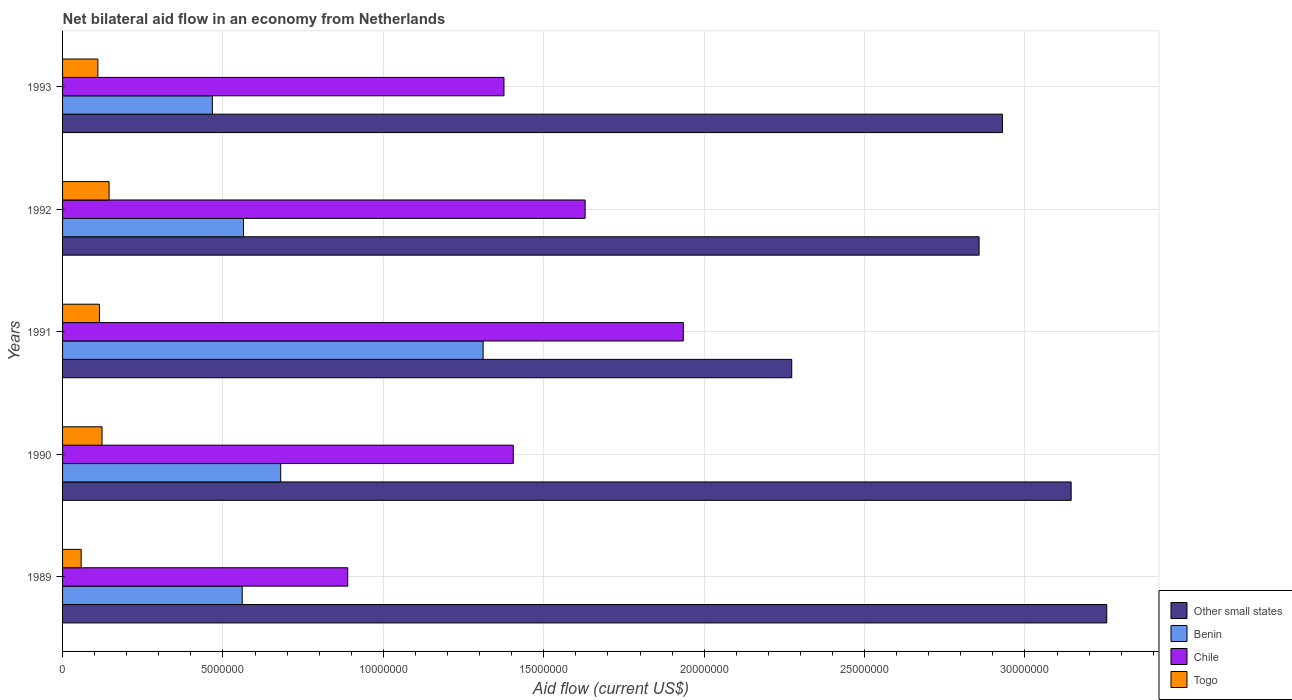How many different coloured bars are there?
Offer a very short reply. 4. How many groups of bars are there?
Ensure brevity in your answer.  5. How many bars are there on the 2nd tick from the top?
Ensure brevity in your answer.  4. How many bars are there on the 4th tick from the bottom?
Provide a short and direct response. 4. In how many cases, is the number of bars for a given year not equal to the number of legend labels?
Provide a short and direct response. 0. What is the net bilateral aid flow in Other small states in 1990?
Provide a succinct answer. 3.14e+07. Across all years, what is the maximum net bilateral aid flow in Benin?
Provide a succinct answer. 1.31e+07. Across all years, what is the minimum net bilateral aid flow in Other small states?
Give a very brief answer. 2.27e+07. In which year was the net bilateral aid flow in Togo maximum?
Your response must be concise. 1992. What is the total net bilateral aid flow in Chile in the graph?
Keep it short and to the point. 7.23e+07. What is the difference between the net bilateral aid flow in Other small states in 1990 and that in 1992?
Make the answer very short. 2.87e+06. What is the difference between the net bilateral aid flow in Chile in 1993 and the net bilateral aid flow in Benin in 1991?
Your answer should be compact. 6.50e+05. What is the average net bilateral aid flow in Chile per year?
Provide a short and direct response. 1.45e+07. In the year 1989, what is the difference between the net bilateral aid flow in Togo and net bilateral aid flow in Benin?
Your response must be concise. -5.02e+06. What is the ratio of the net bilateral aid flow in Benin in 1992 to that in 1993?
Make the answer very short. 1.21. What is the difference between the highest and the second highest net bilateral aid flow in Chile?
Make the answer very short. 3.06e+06. What is the difference between the highest and the lowest net bilateral aid flow in Benin?
Provide a succinct answer. 8.44e+06. In how many years, is the net bilateral aid flow in Togo greater than the average net bilateral aid flow in Togo taken over all years?
Give a very brief answer. 3. Is the sum of the net bilateral aid flow in Other small states in 1989 and 1990 greater than the maximum net bilateral aid flow in Benin across all years?
Offer a very short reply. Yes. Is it the case that in every year, the sum of the net bilateral aid flow in Other small states and net bilateral aid flow in Chile is greater than the sum of net bilateral aid flow in Togo and net bilateral aid flow in Benin?
Give a very brief answer. Yes. What does the 1st bar from the top in 1989 represents?
Your answer should be compact. Togo. What does the 1st bar from the bottom in 1991 represents?
Offer a very short reply. Other small states. How many bars are there?
Make the answer very short. 20. How many years are there in the graph?
Provide a succinct answer. 5. What is the difference between two consecutive major ticks on the X-axis?
Your response must be concise. 5.00e+06. Does the graph contain any zero values?
Provide a short and direct response. No. Does the graph contain grids?
Ensure brevity in your answer.  Yes. What is the title of the graph?
Keep it short and to the point. Net bilateral aid flow in an economy from Netherlands. Does "Cote d'Ivoire" appear as one of the legend labels in the graph?
Offer a terse response. No. What is the label or title of the X-axis?
Offer a terse response. Aid flow (current US$). What is the label or title of the Y-axis?
Make the answer very short. Years. What is the Aid flow (current US$) of Other small states in 1989?
Keep it short and to the point. 3.26e+07. What is the Aid flow (current US$) of Benin in 1989?
Ensure brevity in your answer.  5.60e+06. What is the Aid flow (current US$) in Chile in 1989?
Your answer should be compact. 8.89e+06. What is the Aid flow (current US$) of Togo in 1989?
Your answer should be compact. 5.80e+05. What is the Aid flow (current US$) in Other small states in 1990?
Give a very brief answer. 3.14e+07. What is the Aid flow (current US$) of Benin in 1990?
Give a very brief answer. 6.80e+06. What is the Aid flow (current US$) in Chile in 1990?
Keep it short and to the point. 1.40e+07. What is the Aid flow (current US$) in Togo in 1990?
Make the answer very short. 1.23e+06. What is the Aid flow (current US$) of Other small states in 1991?
Keep it short and to the point. 2.27e+07. What is the Aid flow (current US$) in Benin in 1991?
Provide a short and direct response. 1.31e+07. What is the Aid flow (current US$) of Chile in 1991?
Give a very brief answer. 1.94e+07. What is the Aid flow (current US$) of Togo in 1991?
Provide a short and direct response. 1.15e+06. What is the Aid flow (current US$) in Other small states in 1992?
Make the answer very short. 2.86e+07. What is the Aid flow (current US$) in Benin in 1992?
Make the answer very short. 5.64e+06. What is the Aid flow (current US$) of Chile in 1992?
Ensure brevity in your answer.  1.63e+07. What is the Aid flow (current US$) in Togo in 1992?
Offer a very short reply. 1.45e+06. What is the Aid flow (current US$) in Other small states in 1993?
Offer a terse response. 2.93e+07. What is the Aid flow (current US$) in Benin in 1993?
Offer a very short reply. 4.67e+06. What is the Aid flow (current US$) of Chile in 1993?
Provide a succinct answer. 1.38e+07. What is the Aid flow (current US$) of Togo in 1993?
Offer a terse response. 1.10e+06. Across all years, what is the maximum Aid flow (current US$) of Other small states?
Your answer should be compact. 3.26e+07. Across all years, what is the maximum Aid flow (current US$) of Benin?
Ensure brevity in your answer.  1.31e+07. Across all years, what is the maximum Aid flow (current US$) of Chile?
Offer a very short reply. 1.94e+07. Across all years, what is the maximum Aid flow (current US$) of Togo?
Your answer should be very brief. 1.45e+06. Across all years, what is the minimum Aid flow (current US$) of Other small states?
Your answer should be very brief. 2.27e+07. Across all years, what is the minimum Aid flow (current US$) in Benin?
Provide a succinct answer. 4.67e+06. Across all years, what is the minimum Aid flow (current US$) in Chile?
Give a very brief answer. 8.89e+06. Across all years, what is the minimum Aid flow (current US$) in Togo?
Provide a succinct answer. 5.80e+05. What is the total Aid flow (current US$) of Other small states in the graph?
Offer a very short reply. 1.45e+08. What is the total Aid flow (current US$) of Benin in the graph?
Give a very brief answer. 3.58e+07. What is the total Aid flow (current US$) of Chile in the graph?
Offer a terse response. 7.23e+07. What is the total Aid flow (current US$) of Togo in the graph?
Your answer should be very brief. 5.51e+06. What is the difference between the Aid flow (current US$) in Other small states in 1989 and that in 1990?
Ensure brevity in your answer.  1.11e+06. What is the difference between the Aid flow (current US$) in Benin in 1989 and that in 1990?
Keep it short and to the point. -1.20e+06. What is the difference between the Aid flow (current US$) in Chile in 1989 and that in 1990?
Your answer should be compact. -5.16e+06. What is the difference between the Aid flow (current US$) of Togo in 1989 and that in 1990?
Provide a short and direct response. -6.50e+05. What is the difference between the Aid flow (current US$) of Other small states in 1989 and that in 1991?
Your answer should be compact. 9.82e+06. What is the difference between the Aid flow (current US$) in Benin in 1989 and that in 1991?
Provide a succinct answer. -7.51e+06. What is the difference between the Aid flow (current US$) of Chile in 1989 and that in 1991?
Your answer should be compact. -1.05e+07. What is the difference between the Aid flow (current US$) in Togo in 1989 and that in 1991?
Keep it short and to the point. -5.70e+05. What is the difference between the Aid flow (current US$) in Other small states in 1989 and that in 1992?
Provide a succinct answer. 3.98e+06. What is the difference between the Aid flow (current US$) in Chile in 1989 and that in 1992?
Offer a terse response. -7.40e+06. What is the difference between the Aid flow (current US$) in Togo in 1989 and that in 1992?
Ensure brevity in your answer.  -8.70e+05. What is the difference between the Aid flow (current US$) in Other small states in 1989 and that in 1993?
Keep it short and to the point. 3.25e+06. What is the difference between the Aid flow (current US$) in Benin in 1989 and that in 1993?
Your answer should be very brief. 9.30e+05. What is the difference between the Aid flow (current US$) in Chile in 1989 and that in 1993?
Your answer should be very brief. -4.87e+06. What is the difference between the Aid flow (current US$) in Togo in 1989 and that in 1993?
Offer a terse response. -5.20e+05. What is the difference between the Aid flow (current US$) of Other small states in 1990 and that in 1991?
Your response must be concise. 8.71e+06. What is the difference between the Aid flow (current US$) in Benin in 1990 and that in 1991?
Your answer should be compact. -6.31e+06. What is the difference between the Aid flow (current US$) in Chile in 1990 and that in 1991?
Your answer should be very brief. -5.30e+06. What is the difference between the Aid flow (current US$) of Other small states in 1990 and that in 1992?
Give a very brief answer. 2.87e+06. What is the difference between the Aid flow (current US$) of Benin in 1990 and that in 1992?
Keep it short and to the point. 1.16e+06. What is the difference between the Aid flow (current US$) of Chile in 1990 and that in 1992?
Give a very brief answer. -2.24e+06. What is the difference between the Aid flow (current US$) in Togo in 1990 and that in 1992?
Offer a terse response. -2.20e+05. What is the difference between the Aid flow (current US$) of Other small states in 1990 and that in 1993?
Your answer should be compact. 2.14e+06. What is the difference between the Aid flow (current US$) of Benin in 1990 and that in 1993?
Your response must be concise. 2.13e+06. What is the difference between the Aid flow (current US$) in Togo in 1990 and that in 1993?
Give a very brief answer. 1.30e+05. What is the difference between the Aid flow (current US$) of Other small states in 1991 and that in 1992?
Provide a succinct answer. -5.84e+06. What is the difference between the Aid flow (current US$) of Benin in 1991 and that in 1992?
Your response must be concise. 7.47e+06. What is the difference between the Aid flow (current US$) of Chile in 1991 and that in 1992?
Offer a terse response. 3.06e+06. What is the difference between the Aid flow (current US$) of Other small states in 1991 and that in 1993?
Offer a terse response. -6.57e+06. What is the difference between the Aid flow (current US$) in Benin in 1991 and that in 1993?
Your answer should be compact. 8.44e+06. What is the difference between the Aid flow (current US$) of Chile in 1991 and that in 1993?
Keep it short and to the point. 5.59e+06. What is the difference between the Aid flow (current US$) in Togo in 1991 and that in 1993?
Keep it short and to the point. 5.00e+04. What is the difference between the Aid flow (current US$) in Other small states in 1992 and that in 1993?
Your response must be concise. -7.30e+05. What is the difference between the Aid flow (current US$) of Benin in 1992 and that in 1993?
Ensure brevity in your answer.  9.70e+05. What is the difference between the Aid flow (current US$) of Chile in 1992 and that in 1993?
Give a very brief answer. 2.53e+06. What is the difference between the Aid flow (current US$) in Togo in 1992 and that in 1993?
Your answer should be compact. 3.50e+05. What is the difference between the Aid flow (current US$) in Other small states in 1989 and the Aid flow (current US$) in Benin in 1990?
Your response must be concise. 2.58e+07. What is the difference between the Aid flow (current US$) of Other small states in 1989 and the Aid flow (current US$) of Chile in 1990?
Offer a terse response. 1.85e+07. What is the difference between the Aid flow (current US$) in Other small states in 1989 and the Aid flow (current US$) in Togo in 1990?
Your response must be concise. 3.13e+07. What is the difference between the Aid flow (current US$) in Benin in 1989 and the Aid flow (current US$) in Chile in 1990?
Your response must be concise. -8.45e+06. What is the difference between the Aid flow (current US$) in Benin in 1989 and the Aid flow (current US$) in Togo in 1990?
Keep it short and to the point. 4.37e+06. What is the difference between the Aid flow (current US$) of Chile in 1989 and the Aid flow (current US$) of Togo in 1990?
Keep it short and to the point. 7.66e+06. What is the difference between the Aid flow (current US$) in Other small states in 1989 and the Aid flow (current US$) in Benin in 1991?
Offer a very short reply. 1.94e+07. What is the difference between the Aid flow (current US$) of Other small states in 1989 and the Aid flow (current US$) of Chile in 1991?
Provide a succinct answer. 1.32e+07. What is the difference between the Aid flow (current US$) of Other small states in 1989 and the Aid flow (current US$) of Togo in 1991?
Offer a terse response. 3.14e+07. What is the difference between the Aid flow (current US$) of Benin in 1989 and the Aid flow (current US$) of Chile in 1991?
Provide a short and direct response. -1.38e+07. What is the difference between the Aid flow (current US$) of Benin in 1989 and the Aid flow (current US$) of Togo in 1991?
Provide a succinct answer. 4.45e+06. What is the difference between the Aid flow (current US$) in Chile in 1989 and the Aid flow (current US$) in Togo in 1991?
Provide a short and direct response. 7.74e+06. What is the difference between the Aid flow (current US$) of Other small states in 1989 and the Aid flow (current US$) of Benin in 1992?
Provide a succinct answer. 2.69e+07. What is the difference between the Aid flow (current US$) of Other small states in 1989 and the Aid flow (current US$) of Chile in 1992?
Ensure brevity in your answer.  1.63e+07. What is the difference between the Aid flow (current US$) of Other small states in 1989 and the Aid flow (current US$) of Togo in 1992?
Your answer should be compact. 3.11e+07. What is the difference between the Aid flow (current US$) of Benin in 1989 and the Aid flow (current US$) of Chile in 1992?
Provide a succinct answer. -1.07e+07. What is the difference between the Aid flow (current US$) in Benin in 1989 and the Aid flow (current US$) in Togo in 1992?
Your response must be concise. 4.15e+06. What is the difference between the Aid flow (current US$) of Chile in 1989 and the Aid flow (current US$) of Togo in 1992?
Offer a terse response. 7.44e+06. What is the difference between the Aid flow (current US$) of Other small states in 1989 and the Aid flow (current US$) of Benin in 1993?
Keep it short and to the point. 2.79e+07. What is the difference between the Aid flow (current US$) of Other small states in 1989 and the Aid flow (current US$) of Chile in 1993?
Provide a succinct answer. 1.88e+07. What is the difference between the Aid flow (current US$) of Other small states in 1989 and the Aid flow (current US$) of Togo in 1993?
Provide a short and direct response. 3.14e+07. What is the difference between the Aid flow (current US$) of Benin in 1989 and the Aid flow (current US$) of Chile in 1993?
Provide a succinct answer. -8.16e+06. What is the difference between the Aid flow (current US$) of Benin in 1989 and the Aid flow (current US$) of Togo in 1993?
Provide a short and direct response. 4.50e+06. What is the difference between the Aid flow (current US$) of Chile in 1989 and the Aid flow (current US$) of Togo in 1993?
Your answer should be very brief. 7.79e+06. What is the difference between the Aid flow (current US$) of Other small states in 1990 and the Aid flow (current US$) of Benin in 1991?
Your response must be concise. 1.83e+07. What is the difference between the Aid flow (current US$) in Other small states in 1990 and the Aid flow (current US$) in Chile in 1991?
Offer a very short reply. 1.21e+07. What is the difference between the Aid flow (current US$) in Other small states in 1990 and the Aid flow (current US$) in Togo in 1991?
Ensure brevity in your answer.  3.03e+07. What is the difference between the Aid flow (current US$) of Benin in 1990 and the Aid flow (current US$) of Chile in 1991?
Give a very brief answer. -1.26e+07. What is the difference between the Aid flow (current US$) of Benin in 1990 and the Aid flow (current US$) of Togo in 1991?
Make the answer very short. 5.65e+06. What is the difference between the Aid flow (current US$) in Chile in 1990 and the Aid flow (current US$) in Togo in 1991?
Keep it short and to the point. 1.29e+07. What is the difference between the Aid flow (current US$) in Other small states in 1990 and the Aid flow (current US$) in Benin in 1992?
Your answer should be compact. 2.58e+07. What is the difference between the Aid flow (current US$) of Other small states in 1990 and the Aid flow (current US$) of Chile in 1992?
Provide a short and direct response. 1.52e+07. What is the difference between the Aid flow (current US$) of Other small states in 1990 and the Aid flow (current US$) of Togo in 1992?
Your response must be concise. 3.00e+07. What is the difference between the Aid flow (current US$) of Benin in 1990 and the Aid flow (current US$) of Chile in 1992?
Your answer should be very brief. -9.49e+06. What is the difference between the Aid flow (current US$) of Benin in 1990 and the Aid flow (current US$) of Togo in 1992?
Make the answer very short. 5.35e+06. What is the difference between the Aid flow (current US$) of Chile in 1990 and the Aid flow (current US$) of Togo in 1992?
Provide a succinct answer. 1.26e+07. What is the difference between the Aid flow (current US$) in Other small states in 1990 and the Aid flow (current US$) in Benin in 1993?
Your answer should be compact. 2.68e+07. What is the difference between the Aid flow (current US$) of Other small states in 1990 and the Aid flow (current US$) of Chile in 1993?
Ensure brevity in your answer.  1.77e+07. What is the difference between the Aid flow (current US$) of Other small states in 1990 and the Aid flow (current US$) of Togo in 1993?
Ensure brevity in your answer.  3.03e+07. What is the difference between the Aid flow (current US$) in Benin in 1990 and the Aid flow (current US$) in Chile in 1993?
Keep it short and to the point. -6.96e+06. What is the difference between the Aid flow (current US$) of Benin in 1990 and the Aid flow (current US$) of Togo in 1993?
Your answer should be compact. 5.70e+06. What is the difference between the Aid flow (current US$) in Chile in 1990 and the Aid flow (current US$) in Togo in 1993?
Ensure brevity in your answer.  1.30e+07. What is the difference between the Aid flow (current US$) in Other small states in 1991 and the Aid flow (current US$) in Benin in 1992?
Keep it short and to the point. 1.71e+07. What is the difference between the Aid flow (current US$) in Other small states in 1991 and the Aid flow (current US$) in Chile in 1992?
Provide a short and direct response. 6.44e+06. What is the difference between the Aid flow (current US$) in Other small states in 1991 and the Aid flow (current US$) in Togo in 1992?
Offer a terse response. 2.13e+07. What is the difference between the Aid flow (current US$) in Benin in 1991 and the Aid flow (current US$) in Chile in 1992?
Give a very brief answer. -3.18e+06. What is the difference between the Aid flow (current US$) of Benin in 1991 and the Aid flow (current US$) of Togo in 1992?
Your answer should be compact. 1.17e+07. What is the difference between the Aid flow (current US$) of Chile in 1991 and the Aid flow (current US$) of Togo in 1992?
Offer a terse response. 1.79e+07. What is the difference between the Aid flow (current US$) of Other small states in 1991 and the Aid flow (current US$) of Benin in 1993?
Provide a short and direct response. 1.81e+07. What is the difference between the Aid flow (current US$) in Other small states in 1991 and the Aid flow (current US$) in Chile in 1993?
Your response must be concise. 8.97e+06. What is the difference between the Aid flow (current US$) in Other small states in 1991 and the Aid flow (current US$) in Togo in 1993?
Ensure brevity in your answer.  2.16e+07. What is the difference between the Aid flow (current US$) of Benin in 1991 and the Aid flow (current US$) of Chile in 1993?
Your answer should be compact. -6.50e+05. What is the difference between the Aid flow (current US$) in Benin in 1991 and the Aid flow (current US$) in Togo in 1993?
Give a very brief answer. 1.20e+07. What is the difference between the Aid flow (current US$) in Chile in 1991 and the Aid flow (current US$) in Togo in 1993?
Keep it short and to the point. 1.82e+07. What is the difference between the Aid flow (current US$) in Other small states in 1992 and the Aid flow (current US$) in Benin in 1993?
Offer a very short reply. 2.39e+07. What is the difference between the Aid flow (current US$) in Other small states in 1992 and the Aid flow (current US$) in Chile in 1993?
Provide a succinct answer. 1.48e+07. What is the difference between the Aid flow (current US$) of Other small states in 1992 and the Aid flow (current US$) of Togo in 1993?
Offer a terse response. 2.75e+07. What is the difference between the Aid flow (current US$) in Benin in 1992 and the Aid flow (current US$) in Chile in 1993?
Your answer should be compact. -8.12e+06. What is the difference between the Aid flow (current US$) in Benin in 1992 and the Aid flow (current US$) in Togo in 1993?
Offer a terse response. 4.54e+06. What is the difference between the Aid flow (current US$) in Chile in 1992 and the Aid flow (current US$) in Togo in 1993?
Ensure brevity in your answer.  1.52e+07. What is the average Aid flow (current US$) in Other small states per year?
Offer a terse response. 2.89e+07. What is the average Aid flow (current US$) in Benin per year?
Your response must be concise. 7.16e+06. What is the average Aid flow (current US$) in Chile per year?
Your response must be concise. 1.45e+07. What is the average Aid flow (current US$) in Togo per year?
Provide a short and direct response. 1.10e+06. In the year 1989, what is the difference between the Aid flow (current US$) in Other small states and Aid flow (current US$) in Benin?
Offer a very short reply. 2.70e+07. In the year 1989, what is the difference between the Aid flow (current US$) in Other small states and Aid flow (current US$) in Chile?
Keep it short and to the point. 2.37e+07. In the year 1989, what is the difference between the Aid flow (current US$) of Other small states and Aid flow (current US$) of Togo?
Ensure brevity in your answer.  3.20e+07. In the year 1989, what is the difference between the Aid flow (current US$) in Benin and Aid flow (current US$) in Chile?
Provide a short and direct response. -3.29e+06. In the year 1989, what is the difference between the Aid flow (current US$) in Benin and Aid flow (current US$) in Togo?
Keep it short and to the point. 5.02e+06. In the year 1989, what is the difference between the Aid flow (current US$) of Chile and Aid flow (current US$) of Togo?
Your response must be concise. 8.31e+06. In the year 1990, what is the difference between the Aid flow (current US$) in Other small states and Aid flow (current US$) in Benin?
Your response must be concise. 2.46e+07. In the year 1990, what is the difference between the Aid flow (current US$) of Other small states and Aid flow (current US$) of Chile?
Your answer should be compact. 1.74e+07. In the year 1990, what is the difference between the Aid flow (current US$) of Other small states and Aid flow (current US$) of Togo?
Your response must be concise. 3.02e+07. In the year 1990, what is the difference between the Aid flow (current US$) in Benin and Aid flow (current US$) in Chile?
Make the answer very short. -7.25e+06. In the year 1990, what is the difference between the Aid flow (current US$) in Benin and Aid flow (current US$) in Togo?
Keep it short and to the point. 5.57e+06. In the year 1990, what is the difference between the Aid flow (current US$) of Chile and Aid flow (current US$) of Togo?
Offer a very short reply. 1.28e+07. In the year 1991, what is the difference between the Aid flow (current US$) of Other small states and Aid flow (current US$) of Benin?
Provide a short and direct response. 9.62e+06. In the year 1991, what is the difference between the Aid flow (current US$) in Other small states and Aid flow (current US$) in Chile?
Make the answer very short. 3.38e+06. In the year 1991, what is the difference between the Aid flow (current US$) of Other small states and Aid flow (current US$) of Togo?
Offer a very short reply. 2.16e+07. In the year 1991, what is the difference between the Aid flow (current US$) in Benin and Aid flow (current US$) in Chile?
Provide a succinct answer. -6.24e+06. In the year 1991, what is the difference between the Aid flow (current US$) in Benin and Aid flow (current US$) in Togo?
Provide a succinct answer. 1.20e+07. In the year 1991, what is the difference between the Aid flow (current US$) in Chile and Aid flow (current US$) in Togo?
Keep it short and to the point. 1.82e+07. In the year 1992, what is the difference between the Aid flow (current US$) in Other small states and Aid flow (current US$) in Benin?
Your response must be concise. 2.29e+07. In the year 1992, what is the difference between the Aid flow (current US$) of Other small states and Aid flow (current US$) of Chile?
Offer a very short reply. 1.23e+07. In the year 1992, what is the difference between the Aid flow (current US$) of Other small states and Aid flow (current US$) of Togo?
Give a very brief answer. 2.71e+07. In the year 1992, what is the difference between the Aid flow (current US$) of Benin and Aid flow (current US$) of Chile?
Give a very brief answer. -1.06e+07. In the year 1992, what is the difference between the Aid flow (current US$) of Benin and Aid flow (current US$) of Togo?
Give a very brief answer. 4.19e+06. In the year 1992, what is the difference between the Aid flow (current US$) of Chile and Aid flow (current US$) of Togo?
Your answer should be very brief. 1.48e+07. In the year 1993, what is the difference between the Aid flow (current US$) in Other small states and Aid flow (current US$) in Benin?
Offer a very short reply. 2.46e+07. In the year 1993, what is the difference between the Aid flow (current US$) in Other small states and Aid flow (current US$) in Chile?
Your answer should be very brief. 1.55e+07. In the year 1993, what is the difference between the Aid flow (current US$) of Other small states and Aid flow (current US$) of Togo?
Give a very brief answer. 2.82e+07. In the year 1993, what is the difference between the Aid flow (current US$) of Benin and Aid flow (current US$) of Chile?
Offer a very short reply. -9.09e+06. In the year 1993, what is the difference between the Aid flow (current US$) in Benin and Aid flow (current US$) in Togo?
Your response must be concise. 3.57e+06. In the year 1993, what is the difference between the Aid flow (current US$) of Chile and Aid flow (current US$) of Togo?
Provide a succinct answer. 1.27e+07. What is the ratio of the Aid flow (current US$) of Other small states in 1989 to that in 1990?
Your answer should be very brief. 1.04. What is the ratio of the Aid flow (current US$) in Benin in 1989 to that in 1990?
Your answer should be very brief. 0.82. What is the ratio of the Aid flow (current US$) of Chile in 1989 to that in 1990?
Provide a succinct answer. 0.63. What is the ratio of the Aid flow (current US$) of Togo in 1989 to that in 1990?
Your answer should be compact. 0.47. What is the ratio of the Aid flow (current US$) of Other small states in 1989 to that in 1991?
Your answer should be compact. 1.43. What is the ratio of the Aid flow (current US$) of Benin in 1989 to that in 1991?
Your answer should be compact. 0.43. What is the ratio of the Aid flow (current US$) of Chile in 1989 to that in 1991?
Keep it short and to the point. 0.46. What is the ratio of the Aid flow (current US$) of Togo in 1989 to that in 1991?
Your response must be concise. 0.5. What is the ratio of the Aid flow (current US$) in Other small states in 1989 to that in 1992?
Offer a very short reply. 1.14. What is the ratio of the Aid flow (current US$) in Chile in 1989 to that in 1992?
Offer a terse response. 0.55. What is the ratio of the Aid flow (current US$) in Togo in 1989 to that in 1992?
Provide a succinct answer. 0.4. What is the ratio of the Aid flow (current US$) of Other small states in 1989 to that in 1993?
Your answer should be compact. 1.11. What is the ratio of the Aid flow (current US$) in Benin in 1989 to that in 1993?
Your answer should be compact. 1.2. What is the ratio of the Aid flow (current US$) in Chile in 1989 to that in 1993?
Your answer should be very brief. 0.65. What is the ratio of the Aid flow (current US$) of Togo in 1989 to that in 1993?
Offer a terse response. 0.53. What is the ratio of the Aid flow (current US$) in Other small states in 1990 to that in 1991?
Your response must be concise. 1.38. What is the ratio of the Aid flow (current US$) in Benin in 1990 to that in 1991?
Give a very brief answer. 0.52. What is the ratio of the Aid flow (current US$) of Chile in 1990 to that in 1991?
Provide a short and direct response. 0.73. What is the ratio of the Aid flow (current US$) of Togo in 1990 to that in 1991?
Your response must be concise. 1.07. What is the ratio of the Aid flow (current US$) in Other small states in 1990 to that in 1992?
Ensure brevity in your answer.  1.1. What is the ratio of the Aid flow (current US$) of Benin in 1990 to that in 1992?
Your answer should be very brief. 1.21. What is the ratio of the Aid flow (current US$) in Chile in 1990 to that in 1992?
Ensure brevity in your answer.  0.86. What is the ratio of the Aid flow (current US$) of Togo in 1990 to that in 1992?
Provide a succinct answer. 0.85. What is the ratio of the Aid flow (current US$) of Other small states in 1990 to that in 1993?
Make the answer very short. 1.07. What is the ratio of the Aid flow (current US$) in Benin in 1990 to that in 1993?
Give a very brief answer. 1.46. What is the ratio of the Aid flow (current US$) of Chile in 1990 to that in 1993?
Your answer should be compact. 1.02. What is the ratio of the Aid flow (current US$) in Togo in 1990 to that in 1993?
Your answer should be very brief. 1.12. What is the ratio of the Aid flow (current US$) in Other small states in 1991 to that in 1992?
Offer a very short reply. 0.8. What is the ratio of the Aid flow (current US$) in Benin in 1991 to that in 1992?
Offer a terse response. 2.32. What is the ratio of the Aid flow (current US$) of Chile in 1991 to that in 1992?
Give a very brief answer. 1.19. What is the ratio of the Aid flow (current US$) in Togo in 1991 to that in 1992?
Provide a short and direct response. 0.79. What is the ratio of the Aid flow (current US$) in Other small states in 1991 to that in 1993?
Ensure brevity in your answer.  0.78. What is the ratio of the Aid flow (current US$) in Benin in 1991 to that in 1993?
Make the answer very short. 2.81. What is the ratio of the Aid flow (current US$) of Chile in 1991 to that in 1993?
Your answer should be compact. 1.41. What is the ratio of the Aid flow (current US$) in Togo in 1991 to that in 1993?
Give a very brief answer. 1.05. What is the ratio of the Aid flow (current US$) in Other small states in 1992 to that in 1993?
Your response must be concise. 0.98. What is the ratio of the Aid flow (current US$) in Benin in 1992 to that in 1993?
Offer a terse response. 1.21. What is the ratio of the Aid flow (current US$) in Chile in 1992 to that in 1993?
Provide a succinct answer. 1.18. What is the ratio of the Aid flow (current US$) in Togo in 1992 to that in 1993?
Ensure brevity in your answer.  1.32. What is the difference between the highest and the second highest Aid flow (current US$) in Other small states?
Ensure brevity in your answer.  1.11e+06. What is the difference between the highest and the second highest Aid flow (current US$) in Benin?
Ensure brevity in your answer.  6.31e+06. What is the difference between the highest and the second highest Aid flow (current US$) of Chile?
Offer a very short reply. 3.06e+06. What is the difference between the highest and the lowest Aid flow (current US$) of Other small states?
Provide a succinct answer. 9.82e+06. What is the difference between the highest and the lowest Aid flow (current US$) in Benin?
Offer a terse response. 8.44e+06. What is the difference between the highest and the lowest Aid flow (current US$) of Chile?
Ensure brevity in your answer.  1.05e+07. What is the difference between the highest and the lowest Aid flow (current US$) in Togo?
Your answer should be very brief. 8.70e+05. 